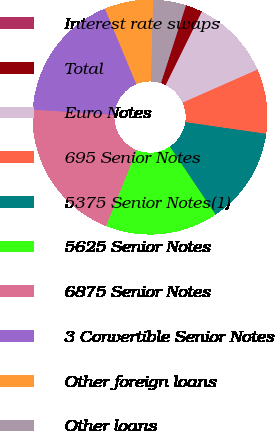Convert chart. <chart><loc_0><loc_0><loc_500><loc_500><pie_chart><fcel>Interest rate swaps<fcel>Total<fcel>Euro Notes<fcel>695 Senior Notes<fcel>5375 Senior Notes(1)<fcel>5625 Senior Notes<fcel>6875 Senior Notes<fcel>3 Convertible Senior Notes<fcel>Other foreign loans<fcel>Other loans<nl><fcel>0.08%<fcel>2.28%<fcel>11.1%<fcel>8.9%<fcel>13.31%<fcel>15.51%<fcel>19.92%<fcel>17.72%<fcel>6.69%<fcel>4.49%<nl></chart> 